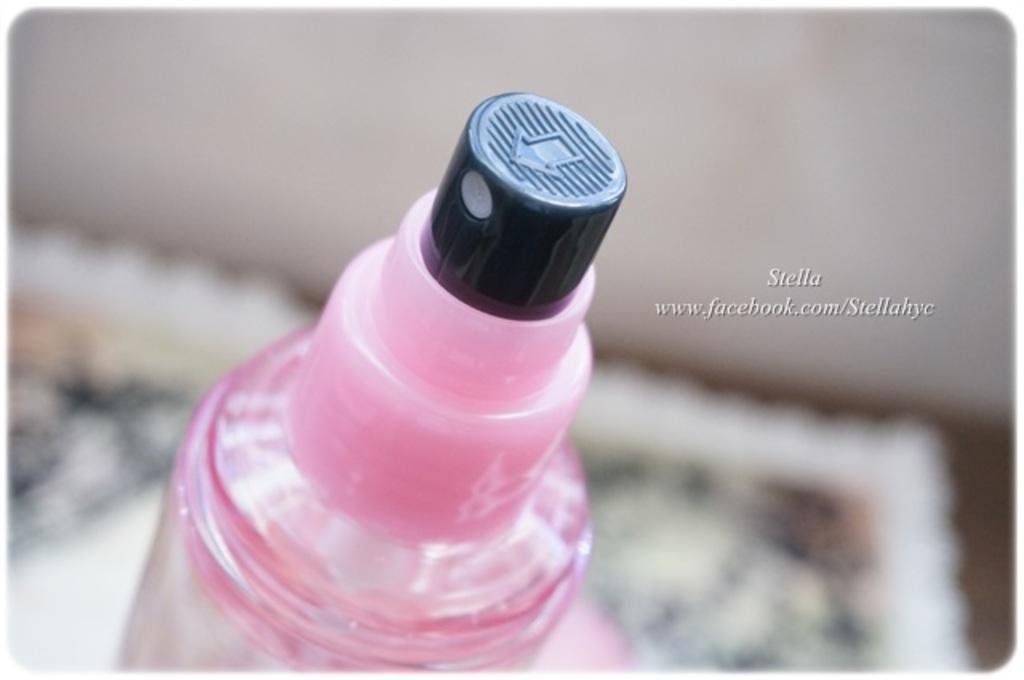Describe this image in one or two sentences. There is a bottle in this image. 